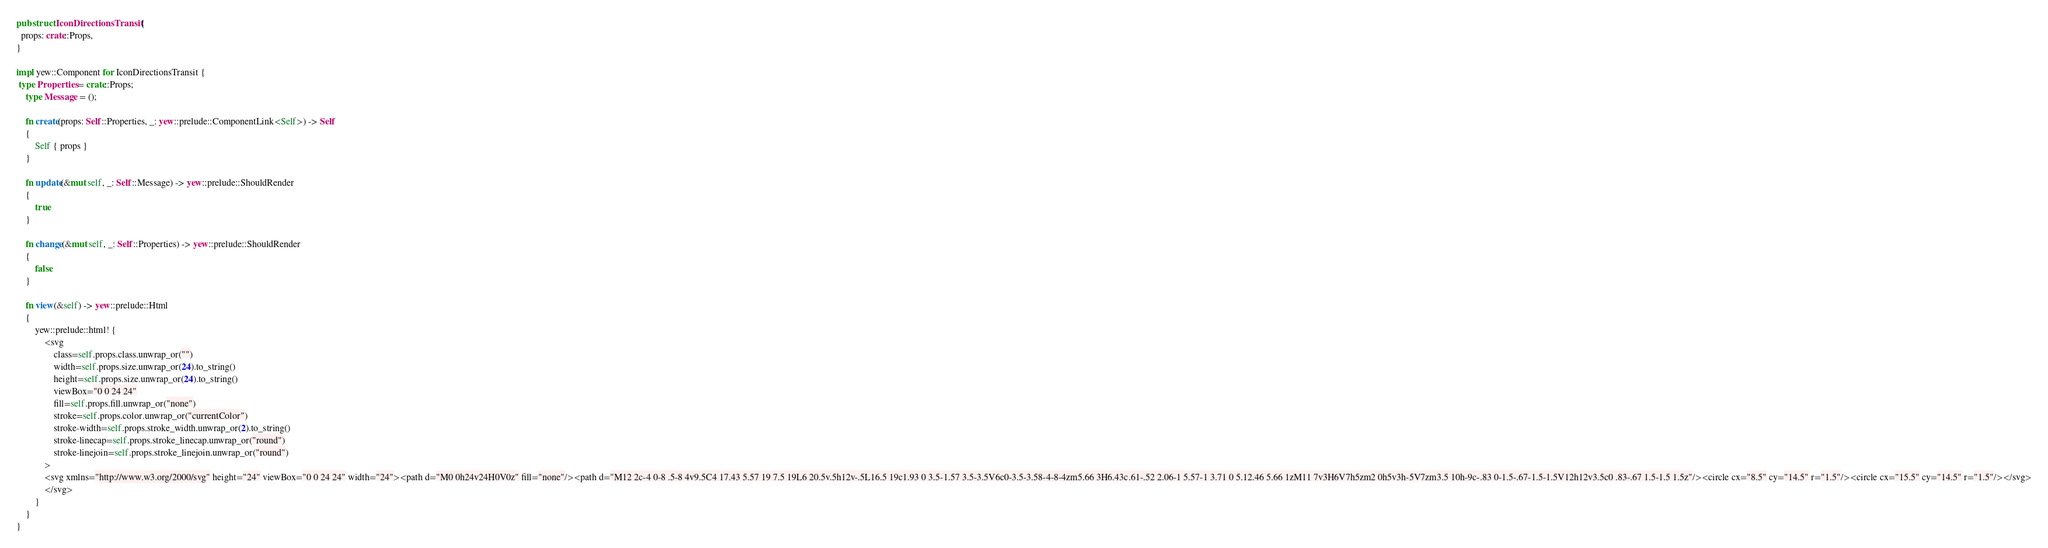Convert code to text. <code><loc_0><loc_0><loc_500><loc_500><_Rust_>
pub struct IconDirectionsTransit {
  props: crate::Props,
}

impl yew::Component for IconDirectionsTransit {
 type Properties = crate::Props;
    type Message = ();

    fn create(props: Self::Properties, _: yew::prelude::ComponentLink<Self>) -> Self
    {
        Self { props }
    }

    fn update(&mut self, _: Self::Message) -> yew::prelude::ShouldRender
    {
        true
    }

    fn change(&mut self, _: Self::Properties) -> yew::prelude::ShouldRender
    {
        false
    }

    fn view(&self) -> yew::prelude::Html
    {
        yew::prelude::html! {
            <svg
                class=self.props.class.unwrap_or("")
                width=self.props.size.unwrap_or(24).to_string()
                height=self.props.size.unwrap_or(24).to_string()
                viewBox="0 0 24 24"
                fill=self.props.fill.unwrap_or("none")
                stroke=self.props.color.unwrap_or("currentColor")
                stroke-width=self.props.stroke_width.unwrap_or(2).to_string()
                stroke-linecap=self.props.stroke_linecap.unwrap_or("round")
                stroke-linejoin=self.props.stroke_linejoin.unwrap_or("round")
            >
            <svg xmlns="http://www.w3.org/2000/svg" height="24" viewBox="0 0 24 24" width="24"><path d="M0 0h24v24H0V0z" fill="none"/><path d="M12 2c-4 0-8 .5-8 4v9.5C4 17.43 5.57 19 7.5 19L6 20.5v.5h12v-.5L16.5 19c1.93 0 3.5-1.57 3.5-3.5V6c0-3.5-3.58-4-8-4zm5.66 3H6.43c.61-.52 2.06-1 5.57-1 3.71 0 5.12.46 5.66 1zM11 7v3H6V7h5zm2 0h5v3h-5V7zm3.5 10h-9c-.83 0-1.5-.67-1.5-1.5V12h12v3.5c0 .83-.67 1.5-1.5 1.5z"/><circle cx="8.5" cy="14.5" r="1.5"/><circle cx="15.5" cy="14.5" r="1.5"/></svg>
            </svg>
        }
    }
}


</code> 